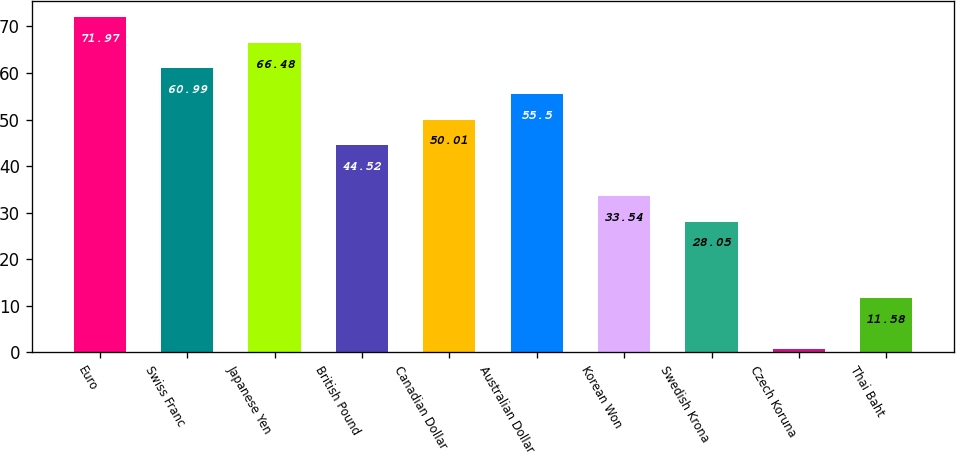Convert chart to OTSL. <chart><loc_0><loc_0><loc_500><loc_500><bar_chart><fcel>Euro<fcel>Swiss Franc<fcel>Japanese Yen<fcel>British Pound<fcel>Canadian Dollar<fcel>Australian Dollar<fcel>Korean Won<fcel>Swedish Krona<fcel>Czech Koruna<fcel>Thai Baht<nl><fcel>71.97<fcel>60.99<fcel>66.48<fcel>44.52<fcel>50.01<fcel>55.5<fcel>33.54<fcel>28.05<fcel>0.6<fcel>11.58<nl></chart> 